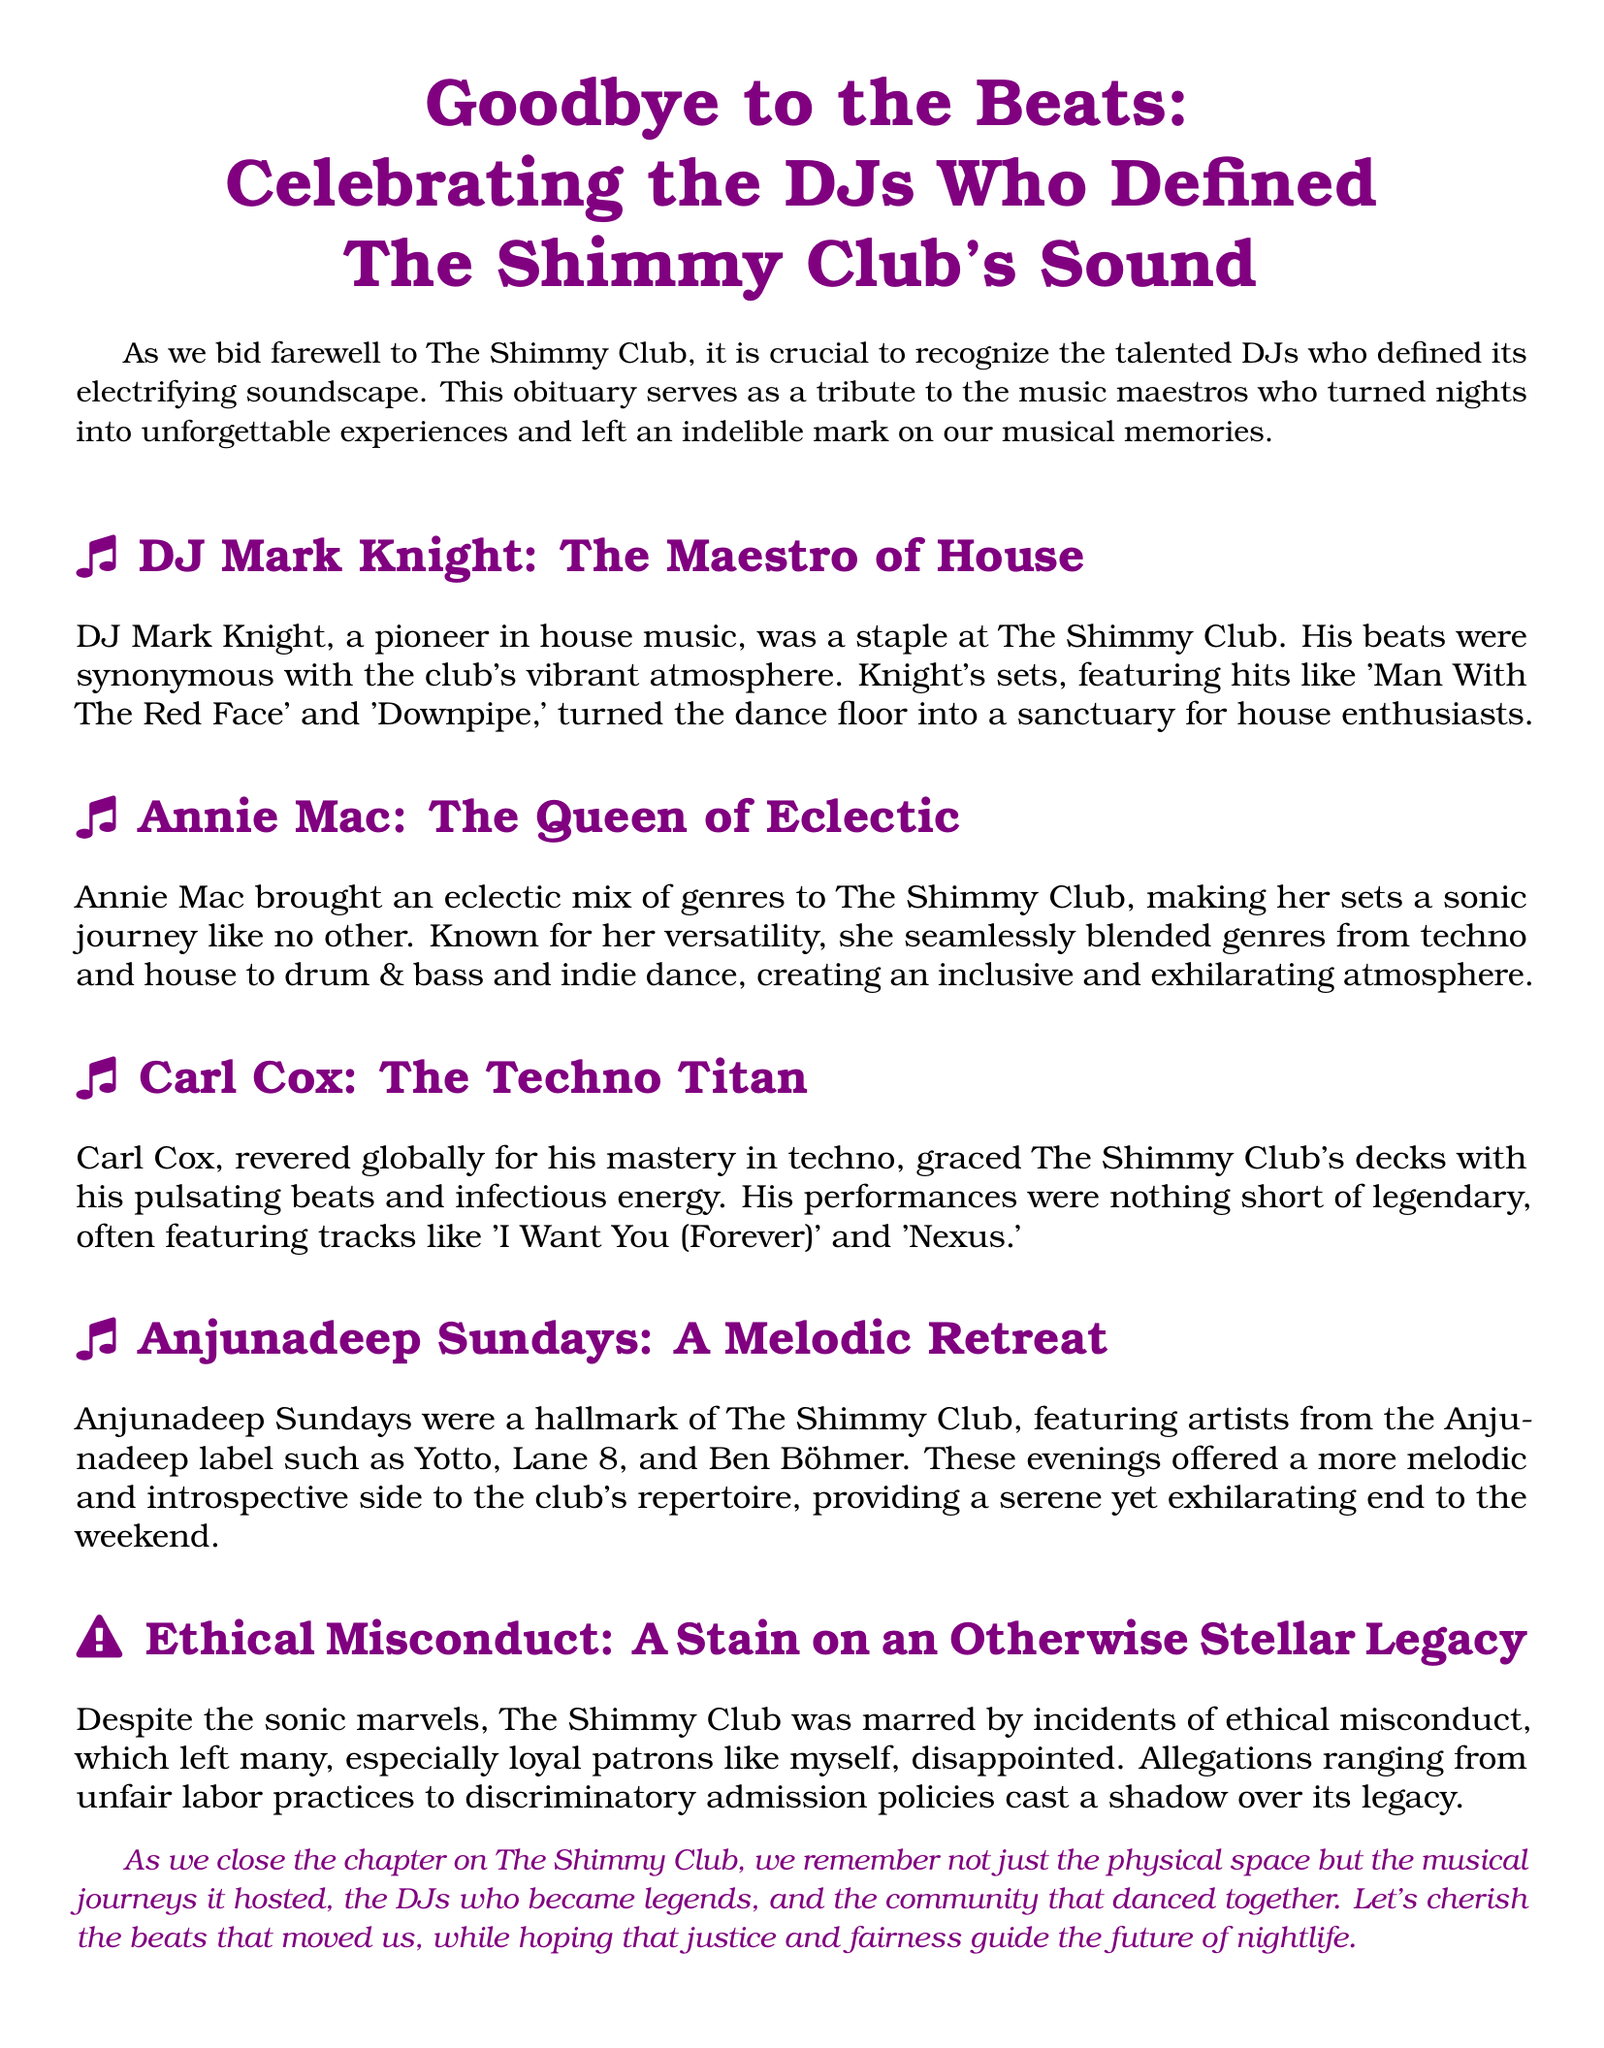What is the title of the obituary? The title of the obituary is presented in a large font at the beginning of the document.
Answer: Goodbye to the Beats: Celebrating the DJs Who Defined The Shimmy Club's Sound Who was known as the "Queen of Eclectic"? This title is attributed to one of the featured DJs in the obituary, highlighting her unique contribution to the club’s music.
Answer: Annie Mac Which DJ is referred to as the "Maestro of House"? This title denotes a specific DJ mentioned in the obituary known for his expertise in house music, showcasing his impact at The Shimmy Club.
Answer: DJ Mark Knight What genre did Carl Cox specialize in? This information is found in the section dedicated to Carl Cox, indicating his focus within the music scene at The Shimmy Club.
Answer: Techno What event marked the end of the weekend at The Shimmy Club? This event is described in the obituary, highlighting a regular musical offering that took place at the club.
Answer: Anjunadeep Sundays What ethical issue affected The Shimmy Club? The document notes specific allegations that tarnished the club’s reputation, which are mentioned under a distinct section.
Answer: Ethical misconduct What type of atmosphere did Annie Mac create with her sets? This refers to the overall experience she crafted during her performances, as described in the obituary.
Answer: Inclusive and exhilarating How did the community respond to the club's ethical misconduct? This reflects the sentiment expressed by the author regarding the club's operating practices.
Answer: Disappointed 